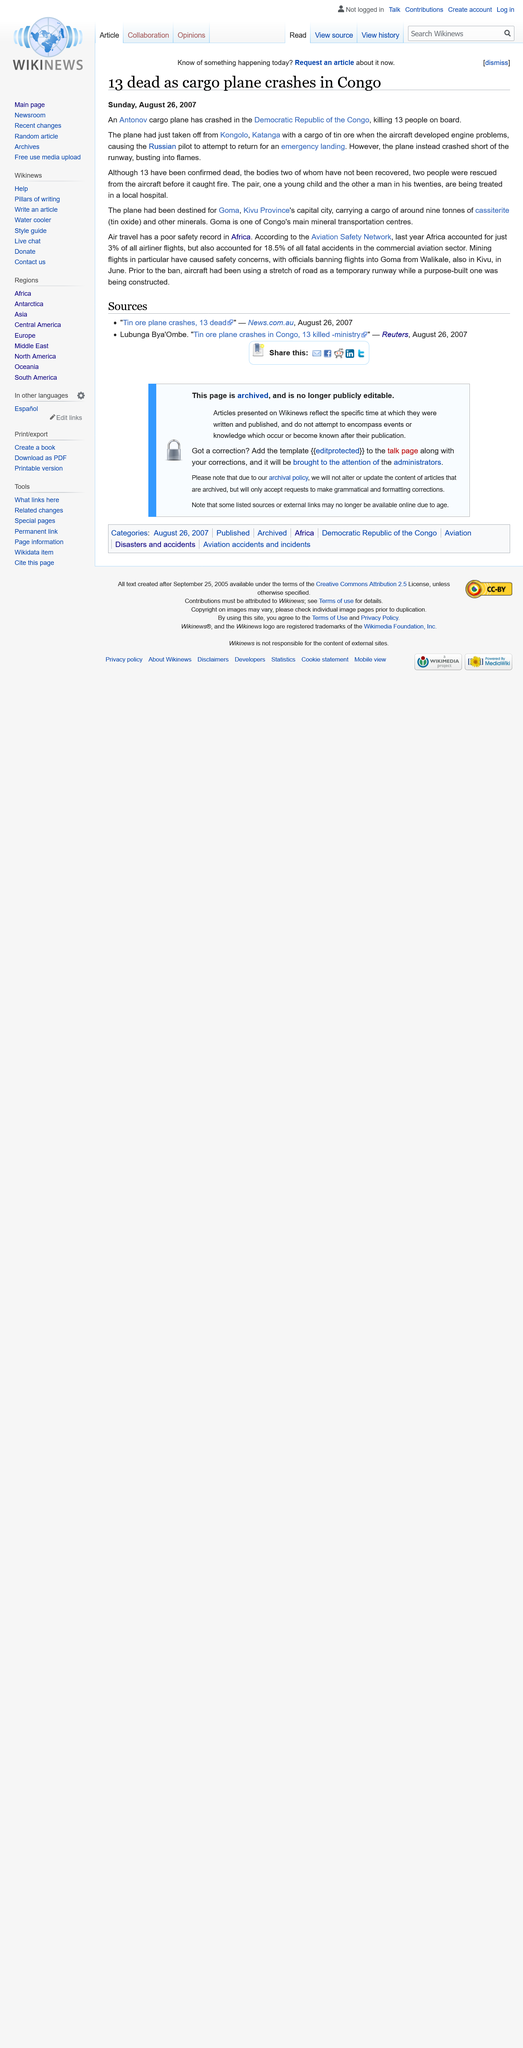Outline some significant characteristics in this image. The crash resulted in the deaths of 13 individuals. On Sunday, August 26, 2007, this was published. According to last year's statistics, a significant percentage of fatal accidents were caused by Africa, with the region accounting for 18.5% of such incidents. 